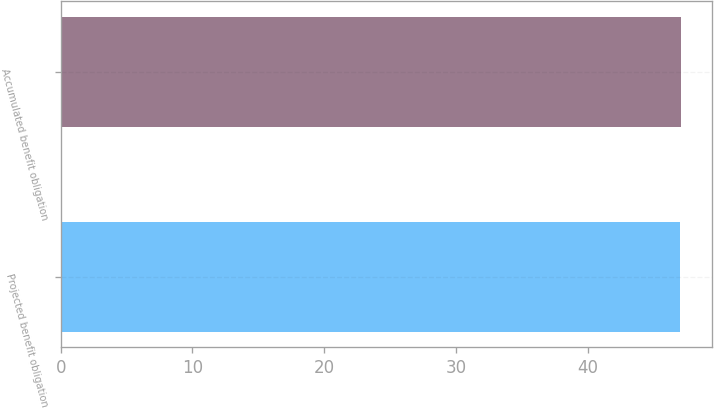<chart> <loc_0><loc_0><loc_500><loc_500><bar_chart><fcel>Projected benefit obligation<fcel>Accumulated benefit obligation<nl><fcel>47<fcel>47.1<nl></chart> 